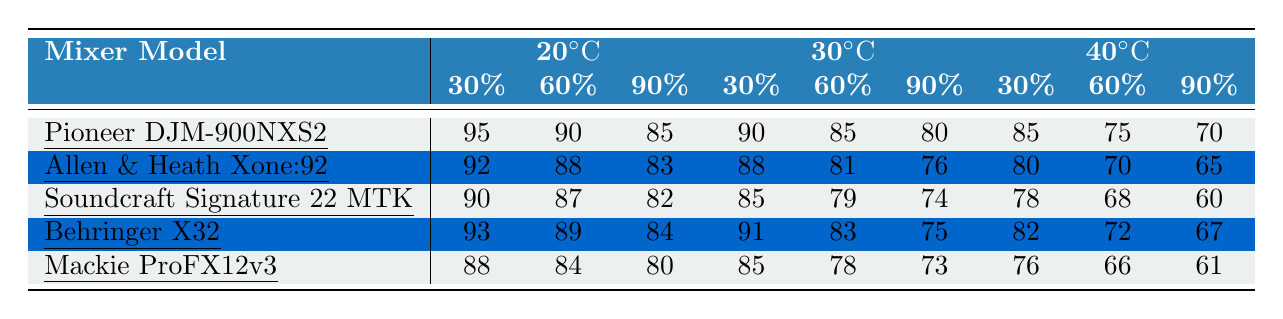What is the performance score of the Pioneer DJM-900NXS2 at 30°C and 60% humidity? The table shows that the performance score for the Pioneer DJM-900NXS2 at 30°C and 60% humidity is 85.
Answer: 85 Which mixer has the highest performance score at 20°C and 30% humidity? According to the table, the Pioneer DJM-900NXS2 has the highest performance score of 95 at 20°C and 30% humidity.
Answer: Pioneer DJM-900NXS2 What is the average performance score of the Behringer X32 across all temperature and humidity conditions? The performance scores of the Behringer X32 are 93, 89, 84, 91, 83, 75, 82, 72, and 67. Adding these scores gives 93 + 89 + 84 + 91 + 83 + 75 + 82 + 72 + 67 =  726. There are 9 scores, so the average is 726/9 = 80.67.
Answer: 80.67 Does the performance of mixers generally decline as temperature or humidity increases? By examining the table, we can see that for most mixers, as either temperature or humidity increases, the performance scores tend to decrease. This trend suggests a general decline in performance under higher conditions.
Answer: Yes Which mixer performs the best under high humidity at 40°C? Looking at the performance scores for 40°C and 90% humidity, the Pioneer DJM-900NXS2 has a score of 70, which is higher than the other mixers (Allen & Heath Xone:92 has 65, Soundcraft Signature 22 MTK has 60, Behringer X32 has 67, and Mackie ProFX12v3 has 61). Hence, the Pioneer DJM-900NXS2 performs best under these conditions.
Answer: Pioneer DJM-900NXS2 What is the difference in performance scores between the Pioneer DJM-900NXS2 and the Allen & Heath Xone:92 at 30°C and 30% humidity? The performance score for Pioneer DJM-900NXS2 at 30°C and 30% humidity is 90, while for the Allen & Heath Xone:92, it is 88. The difference is 90 - 88 = 2.
Answer: 2 Which mixer has the lowest performance score at 40°C and 90% humidity? By checking the data, the mixer that scores the lowest at 40°C and 90% humidity is the Soundcraft Signature 22 MTK with a score of 60.
Answer: Soundcraft Signature 22 MTK If we compare the average performance score of all mixers at 20°C and 60% humidity, which one is the best? The performance scores at 20°C and 60% humidity are: Pioneer DJM-900NXS2 (90), Allen & Heath Xone:92 (88), Soundcraft Signature 22 MTK (87), Behringer X32 (89), and Mackie ProFX12v3 (84). The highest score is from the Pioneer DJM-900NXS2 at 90.
Answer: Pioneer DJM-900NXS2 